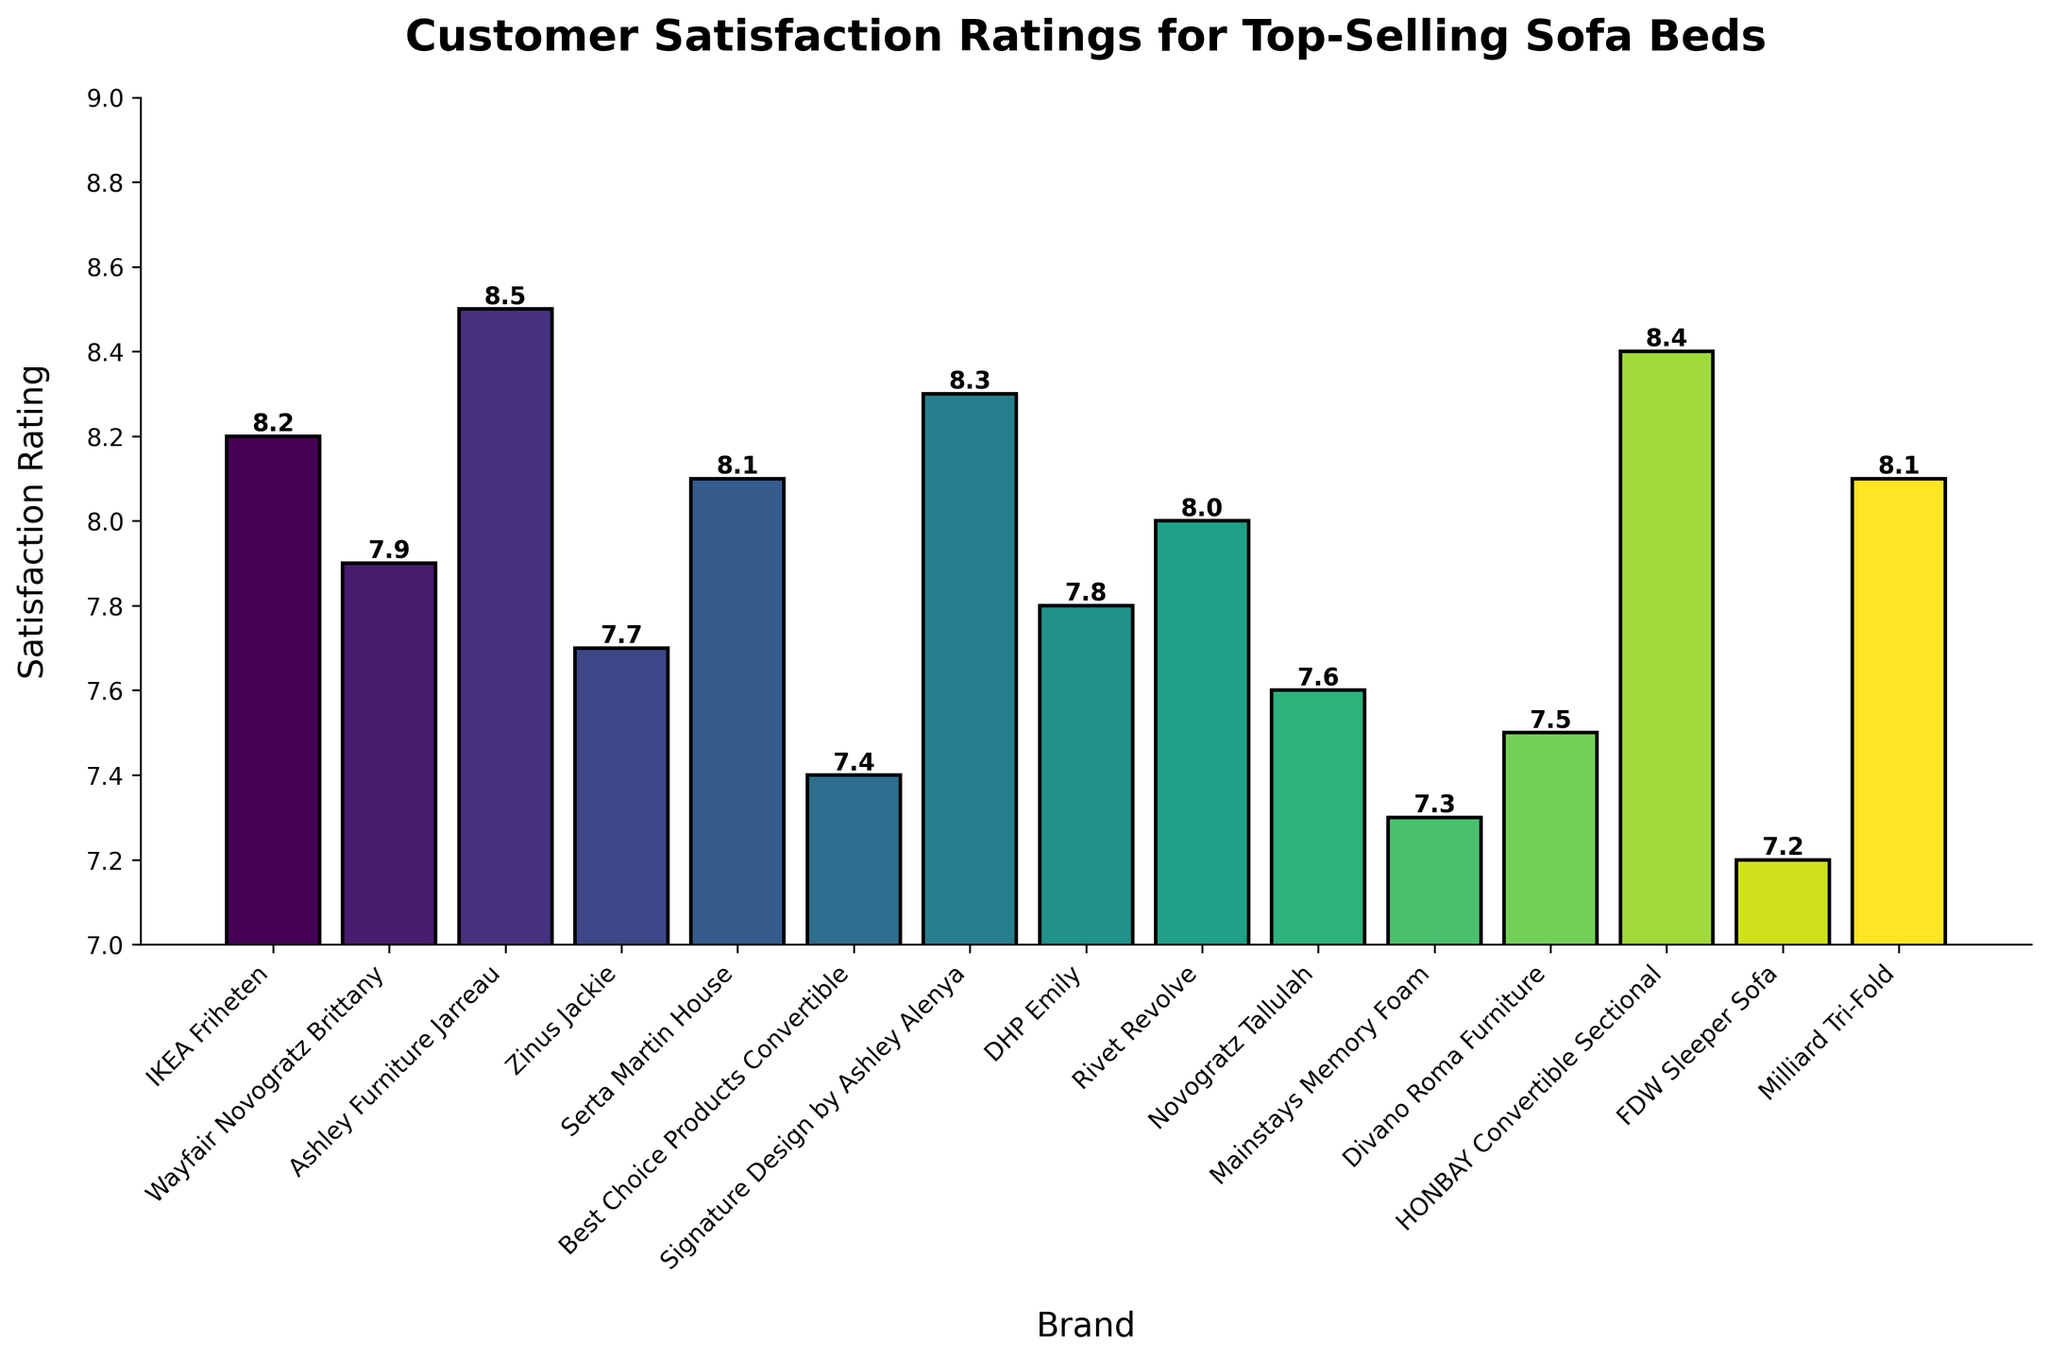Which brand has the highest customer satisfaction rating? To find the brand with the highest customer satisfaction rating, we look for the tallest bar in the bar chart. In the chart, the tallest bar corresponds to Ashley Furniture Jarreau with a rating of 8.5.
Answer: Ashley Furniture Jarreau What is the difference in satisfaction ratings between the highest and lowest-rated brands? First, identify the highest rating (Ashley Furniture Jarreau with 8.5) and the lowest rating (FDW Sleeper Sofa with 7.2). Subtract the lowest rating from the highest rating: 8.5 - 7.2 = 1.3.
Answer: 1.3 How many brands have satisfaction ratings above 8.0? Count the bars that have heights above the 8.0 mark. These include IKEA Friheten (8.2), Ashley Furniture Jarreau (8.5), Serta Martin House (8.1), Signature Design by Ashley Alenya (8.3), HONBAY Convertible Sectional (8.4), and Milliard Tri-Fold (8.1). There are 6 such brands.
Answer: 6 Which brand has a satisfaction rating closest to the average rating of all brands? First, calculate the average satisfaction rating of all brands: (8.2 + 7.9 + 8.5 + 7.7 + 8.1 + 7.4 + 8.3 + 7.8 + 8.0 + 7.6 + 7.3 + 7.5 + 8.4 + 7.2 + 8.1) / 15 = 7.933. Then, find the brand whose rating is closest to 7.933, which is Rivet Revolve with a rating of 8.0.
Answer: Rivet Revolve Are there more brands with ratings above or below 8.0? Count the number of brands above 8.0 and below 8.0. Above 8.0: IKEA Friheten, Ashley Furniture Jarreau, Serta Martin House, Signature Design by Ashley Alenya, HONBAY Convertible Sectional, Milliard Tri-Fold (6 brands). Below 8.0: Wayfair Novogratz Brittany, Zinus Jackie, Best Choice Products Convertible, DHP Emily, Novogratz Tallulah, Mainstays Memory Foam, Divano Roma Furniture, FDW Sleeper Sofa (8 brands). There are more brands with ratings below 8.0.
Answer: Below Which bar has the most intense color? The chart uses a color gradient, typically making the highest value have the most intense color. The bar with the most intense color corresponds to Ashley Furniture Jarreau.
Answer: Ashley Furniture Jarreau What is the sum of the satisfaction ratings for IKEA Friheten and HONBAY Convertible Sectional? Add the satisfaction ratings of IKEA Friheten (8.2) and HONBAY Convertible Sectional (8.4): 8.2 + 8.4 = 16.6.
Answer: 16.6 Is the satisfaction rating of DHP Emily higher than that of Best Choice Products Convertible? Compare the satisfaction ratings of DHP Emily (7.8) and Best Choice Products Convertible (7.4), and note that 7.8 is greater than 7.4.
Answer: Yes How much taller is the bar for Ashley Furniture Jarreau than the bar for Mainstays Memory Foam? Identify the satisfaction ratings for both: Ashley Furniture Jarreau (8.5) and Mainstays Memory Foam (7.3). Calculate the difference: 8.5 - 7.3 = 1.2.
Answer: 1.2 